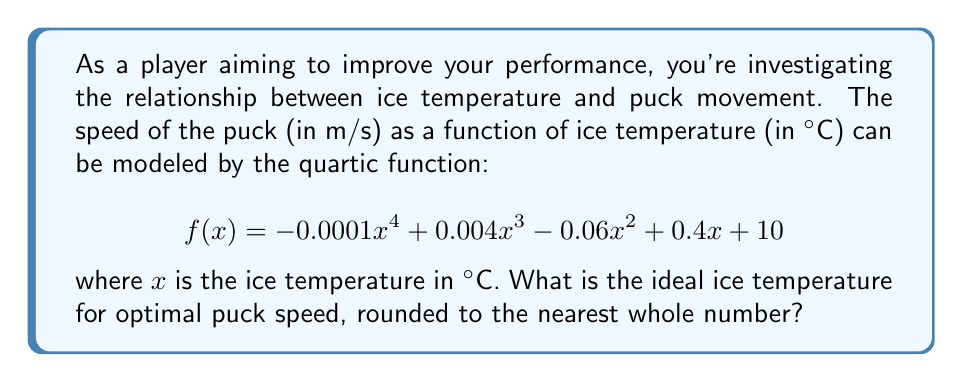Provide a solution to this math problem. To find the ideal ice temperature for optimal puck speed, we need to find the maximum value of the function $f(x)$. For a quartic function, this occurs at a local maximum.

Step 1: Find the derivative of $f(x)$.
$$f'(x) = -0.0004x^3 + 0.012x^2 - 0.12x + 0.4$$

Step 2: Set the derivative equal to zero and solve for x.
$$-0.0004x^3 + 0.012x^2 - 0.12x + 0.4 = 0$$

This equation is difficult to solve algebraically, so we'll use numerical methods or a graphing calculator to find the solutions.

Step 3: The solutions to this equation are approximately:
$x \approx -4.73$, $x \approx 3.31$, and $x \approx 31.42$

Step 4: Evaluate $f''(x)$ at these points to determine which is a local maximum.
$$f''(x) = -0.0012x^2 + 0.024x - 0.12$$

$f''(-4.73) \approx 0.22$ (positive, local minimum)
$f''(3.31) \approx -0.08$ (negative, local maximum)
$f''(31.42) \approx -1.13$ (negative, local maximum)

Step 5: Evaluate $f(x)$ at the two local maxima:
$f(3.31) \approx 11.33$
$f(31.42) \approx -133.76$

Step 6: The higher value occurs at $x \approx 3.31$, which rounded to the nearest whole number is 3°C.
Answer: 3°C 